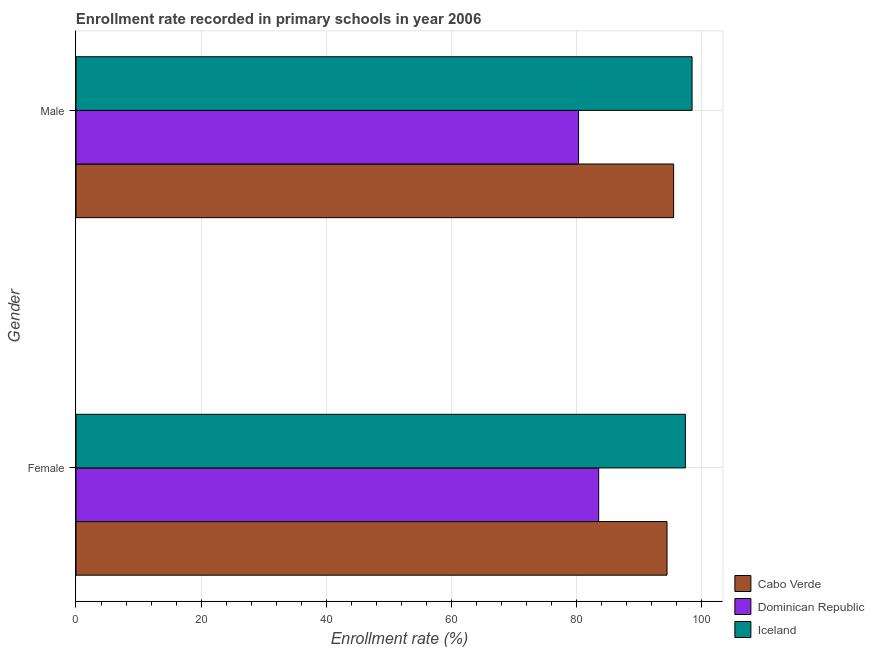How many groups of bars are there?
Give a very brief answer. 2. Are the number of bars per tick equal to the number of legend labels?
Provide a short and direct response. Yes. Are the number of bars on each tick of the Y-axis equal?
Ensure brevity in your answer.  Yes. How many bars are there on the 2nd tick from the top?
Provide a short and direct response. 3. What is the label of the 2nd group of bars from the top?
Provide a succinct answer. Female. What is the enrollment rate of female students in Iceland?
Make the answer very short. 97.41. Across all countries, what is the maximum enrollment rate of male students?
Provide a short and direct response. 98.48. Across all countries, what is the minimum enrollment rate of female students?
Ensure brevity in your answer.  83.56. In which country was the enrollment rate of female students minimum?
Keep it short and to the point. Dominican Republic. What is the total enrollment rate of female students in the graph?
Your response must be concise. 275.45. What is the difference between the enrollment rate of female students in Cabo Verde and that in Iceland?
Your response must be concise. -2.93. What is the difference between the enrollment rate of female students in Dominican Republic and the enrollment rate of male students in Iceland?
Ensure brevity in your answer.  -14.93. What is the average enrollment rate of female students per country?
Offer a terse response. 91.82. What is the difference between the enrollment rate of female students and enrollment rate of male students in Dominican Republic?
Give a very brief answer. 3.22. In how many countries, is the enrollment rate of male students greater than 68 %?
Provide a succinct answer. 3. What is the ratio of the enrollment rate of male students in Cabo Verde to that in Dominican Republic?
Give a very brief answer. 1.19. In how many countries, is the enrollment rate of female students greater than the average enrollment rate of female students taken over all countries?
Your answer should be very brief. 2. What does the 2nd bar from the top in Female represents?
Your answer should be very brief. Dominican Republic. What does the 1st bar from the bottom in Female represents?
Your answer should be very brief. Cabo Verde. How many bars are there?
Give a very brief answer. 6. Are all the bars in the graph horizontal?
Your response must be concise. Yes. How many countries are there in the graph?
Ensure brevity in your answer.  3. What is the difference between two consecutive major ticks on the X-axis?
Your answer should be very brief. 20. Does the graph contain grids?
Offer a terse response. Yes. Where does the legend appear in the graph?
Keep it short and to the point. Bottom right. How many legend labels are there?
Offer a terse response. 3. How are the legend labels stacked?
Provide a succinct answer. Vertical. What is the title of the graph?
Your answer should be very brief. Enrollment rate recorded in primary schools in year 2006. Does "French Polynesia" appear as one of the legend labels in the graph?
Offer a terse response. No. What is the label or title of the X-axis?
Offer a very short reply. Enrollment rate (%). What is the Enrollment rate (%) of Cabo Verde in Female?
Make the answer very short. 94.48. What is the Enrollment rate (%) in Dominican Republic in Female?
Ensure brevity in your answer.  83.56. What is the Enrollment rate (%) in Iceland in Female?
Your answer should be compact. 97.41. What is the Enrollment rate (%) of Cabo Verde in Male?
Your response must be concise. 95.53. What is the Enrollment rate (%) in Dominican Republic in Male?
Your answer should be compact. 80.34. What is the Enrollment rate (%) of Iceland in Male?
Give a very brief answer. 98.48. Across all Gender, what is the maximum Enrollment rate (%) in Cabo Verde?
Offer a terse response. 95.53. Across all Gender, what is the maximum Enrollment rate (%) in Dominican Republic?
Provide a short and direct response. 83.56. Across all Gender, what is the maximum Enrollment rate (%) in Iceland?
Offer a very short reply. 98.48. Across all Gender, what is the minimum Enrollment rate (%) of Cabo Verde?
Your answer should be very brief. 94.48. Across all Gender, what is the minimum Enrollment rate (%) of Dominican Republic?
Ensure brevity in your answer.  80.34. Across all Gender, what is the minimum Enrollment rate (%) in Iceland?
Provide a short and direct response. 97.41. What is the total Enrollment rate (%) of Cabo Verde in the graph?
Your response must be concise. 190.01. What is the total Enrollment rate (%) in Dominican Republic in the graph?
Your answer should be compact. 163.89. What is the total Enrollment rate (%) in Iceland in the graph?
Provide a short and direct response. 195.89. What is the difference between the Enrollment rate (%) of Cabo Verde in Female and that in Male?
Ensure brevity in your answer.  -1.05. What is the difference between the Enrollment rate (%) of Dominican Republic in Female and that in Male?
Provide a succinct answer. 3.22. What is the difference between the Enrollment rate (%) of Iceland in Female and that in Male?
Your answer should be very brief. -1.07. What is the difference between the Enrollment rate (%) of Cabo Verde in Female and the Enrollment rate (%) of Dominican Republic in Male?
Make the answer very short. 14.14. What is the difference between the Enrollment rate (%) of Cabo Verde in Female and the Enrollment rate (%) of Iceland in Male?
Keep it short and to the point. -4. What is the difference between the Enrollment rate (%) of Dominican Republic in Female and the Enrollment rate (%) of Iceland in Male?
Ensure brevity in your answer.  -14.93. What is the average Enrollment rate (%) in Cabo Verde per Gender?
Your answer should be very brief. 95.01. What is the average Enrollment rate (%) in Dominican Republic per Gender?
Provide a short and direct response. 81.95. What is the average Enrollment rate (%) of Iceland per Gender?
Give a very brief answer. 97.95. What is the difference between the Enrollment rate (%) of Cabo Verde and Enrollment rate (%) of Dominican Republic in Female?
Keep it short and to the point. 10.92. What is the difference between the Enrollment rate (%) of Cabo Verde and Enrollment rate (%) of Iceland in Female?
Make the answer very short. -2.93. What is the difference between the Enrollment rate (%) of Dominican Republic and Enrollment rate (%) of Iceland in Female?
Offer a terse response. -13.86. What is the difference between the Enrollment rate (%) of Cabo Verde and Enrollment rate (%) of Dominican Republic in Male?
Ensure brevity in your answer.  15.19. What is the difference between the Enrollment rate (%) in Cabo Verde and Enrollment rate (%) in Iceland in Male?
Offer a very short reply. -2.95. What is the difference between the Enrollment rate (%) in Dominican Republic and Enrollment rate (%) in Iceland in Male?
Your response must be concise. -18.14. What is the ratio of the Enrollment rate (%) in Cabo Verde in Female to that in Male?
Provide a succinct answer. 0.99. What is the ratio of the Enrollment rate (%) of Dominican Republic in Female to that in Male?
Your answer should be compact. 1.04. What is the ratio of the Enrollment rate (%) of Iceland in Female to that in Male?
Provide a short and direct response. 0.99. What is the difference between the highest and the second highest Enrollment rate (%) in Cabo Verde?
Provide a short and direct response. 1.05. What is the difference between the highest and the second highest Enrollment rate (%) of Dominican Republic?
Offer a very short reply. 3.22. What is the difference between the highest and the second highest Enrollment rate (%) in Iceland?
Your answer should be compact. 1.07. What is the difference between the highest and the lowest Enrollment rate (%) in Cabo Verde?
Ensure brevity in your answer.  1.05. What is the difference between the highest and the lowest Enrollment rate (%) in Dominican Republic?
Your answer should be very brief. 3.22. What is the difference between the highest and the lowest Enrollment rate (%) in Iceland?
Your answer should be very brief. 1.07. 